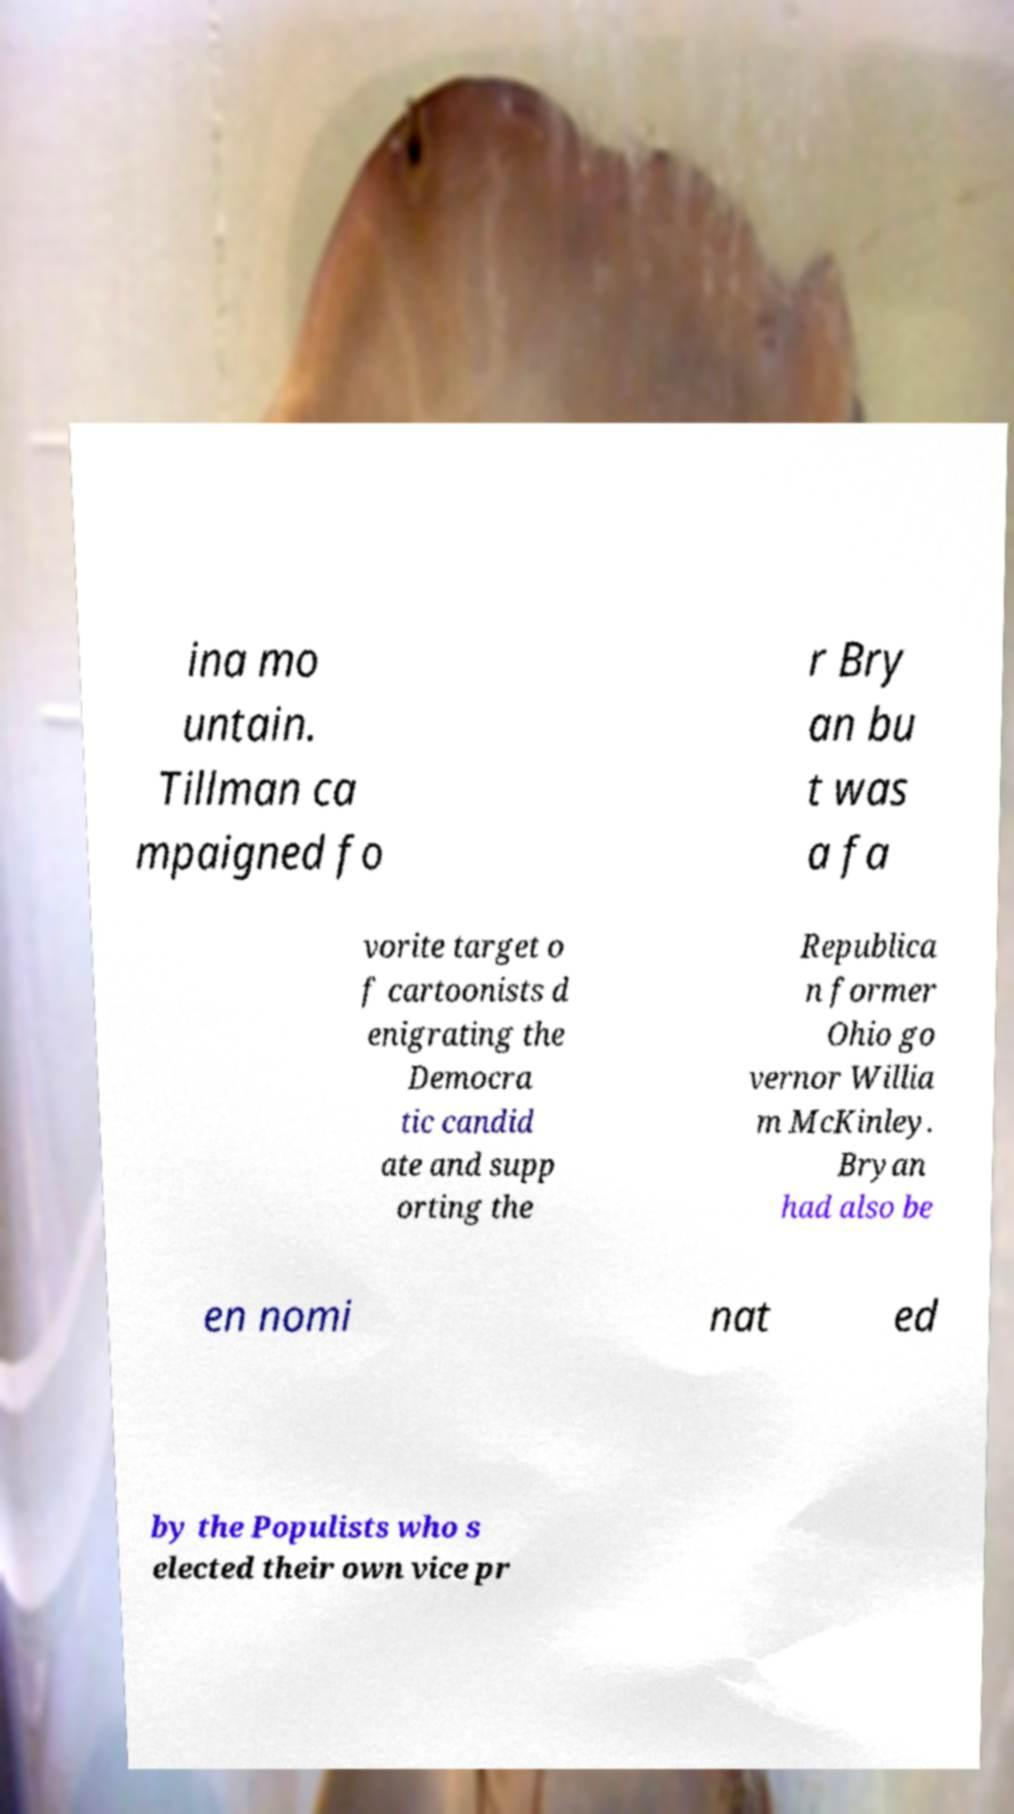Could you extract and type out the text from this image? ina mo untain. Tillman ca mpaigned fo r Bry an bu t was a fa vorite target o f cartoonists d enigrating the Democra tic candid ate and supp orting the Republica n former Ohio go vernor Willia m McKinley. Bryan had also be en nomi nat ed by the Populists who s elected their own vice pr 